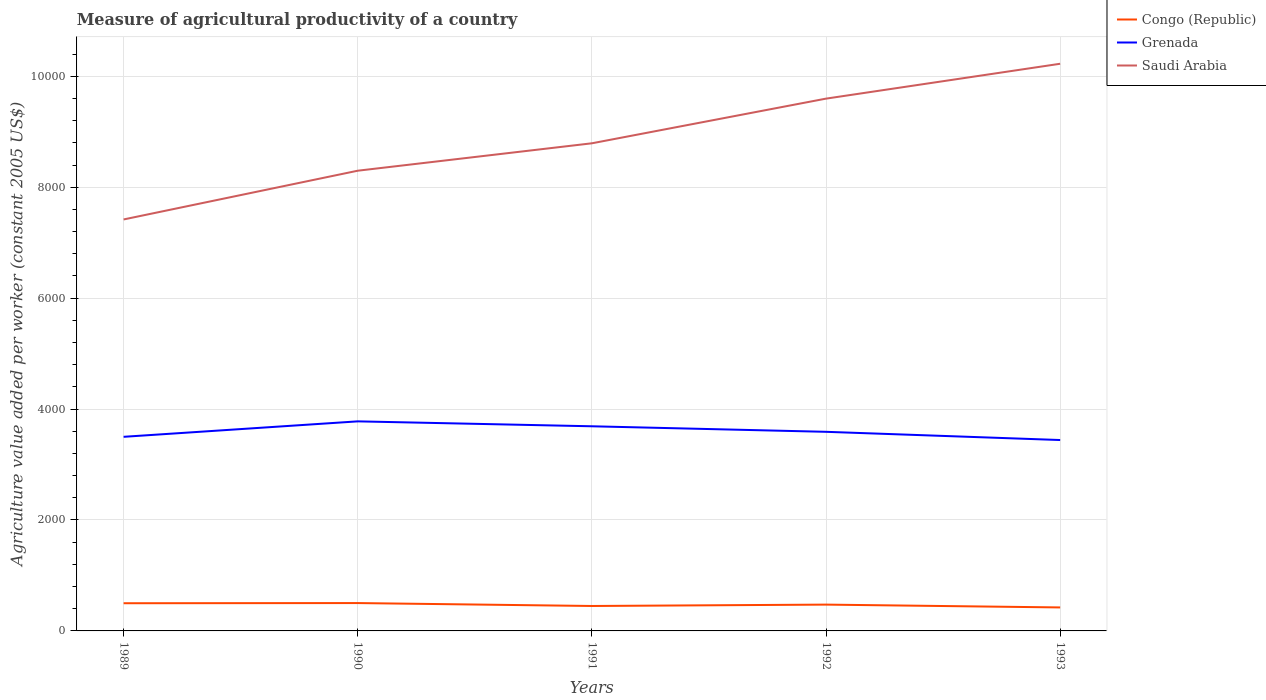How many different coloured lines are there?
Ensure brevity in your answer.  3. Does the line corresponding to Grenada intersect with the line corresponding to Saudi Arabia?
Make the answer very short. No. Across all years, what is the maximum measure of agricultural productivity in Congo (Republic)?
Your response must be concise. 423.48. What is the total measure of agricultural productivity in Grenada in the graph?
Your answer should be compact. 88.54. What is the difference between the highest and the second highest measure of agricultural productivity in Saudi Arabia?
Keep it short and to the point. 2807.13. What is the difference between the highest and the lowest measure of agricultural productivity in Saudi Arabia?
Keep it short and to the point. 2. How many lines are there?
Offer a very short reply. 3. Does the graph contain grids?
Ensure brevity in your answer.  Yes. How many legend labels are there?
Give a very brief answer. 3. What is the title of the graph?
Keep it short and to the point. Measure of agricultural productivity of a country. What is the label or title of the Y-axis?
Provide a short and direct response. Agriculture value added per worker (constant 2005 US$). What is the Agriculture value added per worker (constant 2005 US$) of Congo (Republic) in 1989?
Your answer should be very brief. 499.07. What is the Agriculture value added per worker (constant 2005 US$) of Grenada in 1989?
Ensure brevity in your answer.  3499.77. What is the Agriculture value added per worker (constant 2005 US$) of Saudi Arabia in 1989?
Your response must be concise. 7418.83. What is the Agriculture value added per worker (constant 2005 US$) in Congo (Republic) in 1990?
Provide a short and direct response. 502.42. What is the Agriculture value added per worker (constant 2005 US$) in Grenada in 1990?
Provide a short and direct response. 3778.33. What is the Agriculture value added per worker (constant 2005 US$) in Saudi Arabia in 1990?
Your answer should be compact. 8297.64. What is the Agriculture value added per worker (constant 2005 US$) of Congo (Republic) in 1991?
Offer a very short reply. 449.61. What is the Agriculture value added per worker (constant 2005 US$) of Grenada in 1991?
Offer a terse response. 3689.78. What is the Agriculture value added per worker (constant 2005 US$) in Saudi Arabia in 1991?
Keep it short and to the point. 8791.87. What is the Agriculture value added per worker (constant 2005 US$) in Congo (Republic) in 1992?
Ensure brevity in your answer.  474.3. What is the Agriculture value added per worker (constant 2005 US$) in Grenada in 1992?
Keep it short and to the point. 3590.03. What is the Agriculture value added per worker (constant 2005 US$) in Saudi Arabia in 1992?
Make the answer very short. 9597.26. What is the Agriculture value added per worker (constant 2005 US$) of Congo (Republic) in 1993?
Your answer should be compact. 423.48. What is the Agriculture value added per worker (constant 2005 US$) in Grenada in 1993?
Offer a terse response. 3441.87. What is the Agriculture value added per worker (constant 2005 US$) in Saudi Arabia in 1993?
Provide a short and direct response. 1.02e+04. Across all years, what is the maximum Agriculture value added per worker (constant 2005 US$) in Congo (Republic)?
Your answer should be very brief. 502.42. Across all years, what is the maximum Agriculture value added per worker (constant 2005 US$) of Grenada?
Ensure brevity in your answer.  3778.33. Across all years, what is the maximum Agriculture value added per worker (constant 2005 US$) in Saudi Arabia?
Offer a terse response. 1.02e+04. Across all years, what is the minimum Agriculture value added per worker (constant 2005 US$) of Congo (Republic)?
Keep it short and to the point. 423.48. Across all years, what is the minimum Agriculture value added per worker (constant 2005 US$) in Grenada?
Provide a succinct answer. 3441.87. Across all years, what is the minimum Agriculture value added per worker (constant 2005 US$) of Saudi Arabia?
Your answer should be compact. 7418.83. What is the total Agriculture value added per worker (constant 2005 US$) in Congo (Republic) in the graph?
Offer a very short reply. 2348.88. What is the total Agriculture value added per worker (constant 2005 US$) of Grenada in the graph?
Offer a terse response. 1.80e+04. What is the total Agriculture value added per worker (constant 2005 US$) in Saudi Arabia in the graph?
Offer a very short reply. 4.43e+04. What is the difference between the Agriculture value added per worker (constant 2005 US$) of Congo (Republic) in 1989 and that in 1990?
Your answer should be very brief. -3.35. What is the difference between the Agriculture value added per worker (constant 2005 US$) of Grenada in 1989 and that in 1990?
Offer a terse response. -278.56. What is the difference between the Agriculture value added per worker (constant 2005 US$) of Saudi Arabia in 1989 and that in 1990?
Your answer should be very brief. -878.81. What is the difference between the Agriculture value added per worker (constant 2005 US$) of Congo (Republic) in 1989 and that in 1991?
Offer a very short reply. 49.46. What is the difference between the Agriculture value added per worker (constant 2005 US$) of Grenada in 1989 and that in 1991?
Your answer should be compact. -190.01. What is the difference between the Agriculture value added per worker (constant 2005 US$) in Saudi Arabia in 1989 and that in 1991?
Keep it short and to the point. -1373.04. What is the difference between the Agriculture value added per worker (constant 2005 US$) of Congo (Republic) in 1989 and that in 1992?
Provide a short and direct response. 24.77. What is the difference between the Agriculture value added per worker (constant 2005 US$) in Grenada in 1989 and that in 1992?
Your answer should be compact. -90.26. What is the difference between the Agriculture value added per worker (constant 2005 US$) of Saudi Arabia in 1989 and that in 1992?
Keep it short and to the point. -2178.43. What is the difference between the Agriculture value added per worker (constant 2005 US$) of Congo (Republic) in 1989 and that in 1993?
Make the answer very short. 75.59. What is the difference between the Agriculture value added per worker (constant 2005 US$) of Grenada in 1989 and that in 1993?
Give a very brief answer. 57.9. What is the difference between the Agriculture value added per worker (constant 2005 US$) in Saudi Arabia in 1989 and that in 1993?
Provide a succinct answer. -2807.13. What is the difference between the Agriculture value added per worker (constant 2005 US$) in Congo (Republic) in 1990 and that in 1991?
Your answer should be very brief. 52.81. What is the difference between the Agriculture value added per worker (constant 2005 US$) in Grenada in 1990 and that in 1991?
Ensure brevity in your answer.  88.54. What is the difference between the Agriculture value added per worker (constant 2005 US$) in Saudi Arabia in 1990 and that in 1991?
Give a very brief answer. -494.23. What is the difference between the Agriculture value added per worker (constant 2005 US$) of Congo (Republic) in 1990 and that in 1992?
Ensure brevity in your answer.  28.12. What is the difference between the Agriculture value added per worker (constant 2005 US$) in Grenada in 1990 and that in 1992?
Give a very brief answer. 188.3. What is the difference between the Agriculture value added per worker (constant 2005 US$) of Saudi Arabia in 1990 and that in 1992?
Ensure brevity in your answer.  -1299.62. What is the difference between the Agriculture value added per worker (constant 2005 US$) of Congo (Republic) in 1990 and that in 1993?
Offer a terse response. 78.95. What is the difference between the Agriculture value added per worker (constant 2005 US$) of Grenada in 1990 and that in 1993?
Make the answer very short. 336.46. What is the difference between the Agriculture value added per worker (constant 2005 US$) in Saudi Arabia in 1990 and that in 1993?
Provide a short and direct response. -1928.32. What is the difference between the Agriculture value added per worker (constant 2005 US$) in Congo (Republic) in 1991 and that in 1992?
Keep it short and to the point. -24.69. What is the difference between the Agriculture value added per worker (constant 2005 US$) in Grenada in 1991 and that in 1992?
Your answer should be very brief. 99.75. What is the difference between the Agriculture value added per worker (constant 2005 US$) in Saudi Arabia in 1991 and that in 1992?
Your answer should be very brief. -805.39. What is the difference between the Agriculture value added per worker (constant 2005 US$) of Congo (Republic) in 1991 and that in 1993?
Offer a very short reply. 26.13. What is the difference between the Agriculture value added per worker (constant 2005 US$) of Grenada in 1991 and that in 1993?
Give a very brief answer. 247.91. What is the difference between the Agriculture value added per worker (constant 2005 US$) in Saudi Arabia in 1991 and that in 1993?
Provide a short and direct response. -1434.09. What is the difference between the Agriculture value added per worker (constant 2005 US$) in Congo (Republic) in 1992 and that in 1993?
Make the answer very short. 50.83. What is the difference between the Agriculture value added per worker (constant 2005 US$) of Grenada in 1992 and that in 1993?
Provide a succinct answer. 148.16. What is the difference between the Agriculture value added per worker (constant 2005 US$) of Saudi Arabia in 1992 and that in 1993?
Ensure brevity in your answer.  -628.7. What is the difference between the Agriculture value added per worker (constant 2005 US$) in Congo (Republic) in 1989 and the Agriculture value added per worker (constant 2005 US$) in Grenada in 1990?
Provide a succinct answer. -3279.26. What is the difference between the Agriculture value added per worker (constant 2005 US$) of Congo (Republic) in 1989 and the Agriculture value added per worker (constant 2005 US$) of Saudi Arabia in 1990?
Make the answer very short. -7798.57. What is the difference between the Agriculture value added per worker (constant 2005 US$) of Grenada in 1989 and the Agriculture value added per worker (constant 2005 US$) of Saudi Arabia in 1990?
Ensure brevity in your answer.  -4797.87. What is the difference between the Agriculture value added per worker (constant 2005 US$) of Congo (Republic) in 1989 and the Agriculture value added per worker (constant 2005 US$) of Grenada in 1991?
Provide a short and direct response. -3190.71. What is the difference between the Agriculture value added per worker (constant 2005 US$) in Congo (Republic) in 1989 and the Agriculture value added per worker (constant 2005 US$) in Saudi Arabia in 1991?
Your answer should be very brief. -8292.8. What is the difference between the Agriculture value added per worker (constant 2005 US$) of Grenada in 1989 and the Agriculture value added per worker (constant 2005 US$) of Saudi Arabia in 1991?
Keep it short and to the point. -5292.1. What is the difference between the Agriculture value added per worker (constant 2005 US$) of Congo (Republic) in 1989 and the Agriculture value added per worker (constant 2005 US$) of Grenada in 1992?
Your answer should be very brief. -3090.96. What is the difference between the Agriculture value added per worker (constant 2005 US$) of Congo (Republic) in 1989 and the Agriculture value added per worker (constant 2005 US$) of Saudi Arabia in 1992?
Your response must be concise. -9098.19. What is the difference between the Agriculture value added per worker (constant 2005 US$) in Grenada in 1989 and the Agriculture value added per worker (constant 2005 US$) in Saudi Arabia in 1992?
Your response must be concise. -6097.49. What is the difference between the Agriculture value added per worker (constant 2005 US$) in Congo (Republic) in 1989 and the Agriculture value added per worker (constant 2005 US$) in Grenada in 1993?
Provide a succinct answer. -2942.8. What is the difference between the Agriculture value added per worker (constant 2005 US$) of Congo (Republic) in 1989 and the Agriculture value added per worker (constant 2005 US$) of Saudi Arabia in 1993?
Give a very brief answer. -9726.89. What is the difference between the Agriculture value added per worker (constant 2005 US$) in Grenada in 1989 and the Agriculture value added per worker (constant 2005 US$) in Saudi Arabia in 1993?
Your answer should be compact. -6726.19. What is the difference between the Agriculture value added per worker (constant 2005 US$) in Congo (Republic) in 1990 and the Agriculture value added per worker (constant 2005 US$) in Grenada in 1991?
Your response must be concise. -3187.36. What is the difference between the Agriculture value added per worker (constant 2005 US$) in Congo (Republic) in 1990 and the Agriculture value added per worker (constant 2005 US$) in Saudi Arabia in 1991?
Keep it short and to the point. -8289.45. What is the difference between the Agriculture value added per worker (constant 2005 US$) in Grenada in 1990 and the Agriculture value added per worker (constant 2005 US$) in Saudi Arabia in 1991?
Your answer should be compact. -5013.55. What is the difference between the Agriculture value added per worker (constant 2005 US$) in Congo (Republic) in 1990 and the Agriculture value added per worker (constant 2005 US$) in Grenada in 1992?
Keep it short and to the point. -3087.6. What is the difference between the Agriculture value added per worker (constant 2005 US$) of Congo (Republic) in 1990 and the Agriculture value added per worker (constant 2005 US$) of Saudi Arabia in 1992?
Your answer should be very brief. -9094.84. What is the difference between the Agriculture value added per worker (constant 2005 US$) in Grenada in 1990 and the Agriculture value added per worker (constant 2005 US$) in Saudi Arabia in 1992?
Provide a short and direct response. -5818.94. What is the difference between the Agriculture value added per worker (constant 2005 US$) of Congo (Republic) in 1990 and the Agriculture value added per worker (constant 2005 US$) of Grenada in 1993?
Provide a succinct answer. -2939.45. What is the difference between the Agriculture value added per worker (constant 2005 US$) in Congo (Republic) in 1990 and the Agriculture value added per worker (constant 2005 US$) in Saudi Arabia in 1993?
Keep it short and to the point. -9723.54. What is the difference between the Agriculture value added per worker (constant 2005 US$) in Grenada in 1990 and the Agriculture value added per worker (constant 2005 US$) in Saudi Arabia in 1993?
Keep it short and to the point. -6447.64. What is the difference between the Agriculture value added per worker (constant 2005 US$) in Congo (Republic) in 1991 and the Agriculture value added per worker (constant 2005 US$) in Grenada in 1992?
Offer a terse response. -3140.42. What is the difference between the Agriculture value added per worker (constant 2005 US$) in Congo (Republic) in 1991 and the Agriculture value added per worker (constant 2005 US$) in Saudi Arabia in 1992?
Provide a short and direct response. -9147.65. What is the difference between the Agriculture value added per worker (constant 2005 US$) of Grenada in 1991 and the Agriculture value added per worker (constant 2005 US$) of Saudi Arabia in 1992?
Keep it short and to the point. -5907.48. What is the difference between the Agriculture value added per worker (constant 2005 US$) of Congo (Republic) in 1991 and the Agriculture value added per worker (constant 2005 US$) of Grenada in 1993?
Provide a short and direct response. -2992.26. What is the difference between the Agriculture value added per worker (constant 2005 US$) of Congo (Republic) in 1991 and the Agriculture value added per worker (constant 2005 US$) of Saudi Arabia in 1993?
Offer a terse response. -9776.35. What is the difference between the Agriculture value added per worker (constant 2005 US$) of Grenada in 1991 and the Agriculture value added per worker (constant 2005 US$) of Saudi Arabia in 1993?
Provide a short and direct response. -6536.18. What is the difference between the Agriculture value added per worker (constant 2005 US$) of Congo (Republic) in 1992 and the Agriculture value added per worker (constant 2005 US$) of Grenada in 1993?
Offer a terse response. -2967.57. What is the difference between the Agriculture value added per worker (constant 2005 US$) of Congo (Republic) in 1992 and the Agriculture value added per worker (constant 2005 US$) of Saudi Arabia in 1993?
Make the answer very short. -9751.66. What is the difference between the Agriculture value added per worker (constant 2005 US$) of Grenada in 1992 and the Agriculture value added per worker (constant 2005 US$) of Saudi Arabia in 1993?
Your answer should be very brief. -6635.94. What is the average Agriculture value added per worker (constant 2005 US$) in Congo (Republic) per year?
Keep it short and to the point. 469.78. What is the average Agriculture value added per worker (constant 2005 US$) in Grenada per year?
Offer a very short reply. 3599.96. What is the average Agriculture value added per worker (constant 2005 US$) of Saudi Arabia per year?
Provide a short and direct response. 8866.31. In the year 1989, what is the difference between the Agriculture value added per worker (constant 2005 US$) in Congo (Republic) and Agriculture value added per worker (constant 2005 US$) in Grenada?
Your answer should be very brief. -3000.7. In the year 1989, what is the difference between the Agriculture value added per worker (constant 2005 US$) in Congo (Republic) and Agriculture value added per worker (constant 2005 US$) in Saudi Arabia?
Give a very brief answer. -6919.76. In the year 1989, what is the difference between the Agriculture value added per worker (constant 2005 US$) of Grenada and Agriculture value added per worker (constant 2005 US$) of Saudi Arabia?
Make the answer very short. -3919.06. In the year 1990, what is the difference between the Agriculture value added per worker (constant 2005 US$) in Congo (Republic) and Agriculture value added per worker (constant 2005 US$) in Grenada?
Give a very brief answer. -3275.9. In the year 1990, what is the difference between the Agriculture value added per worker (constant 2005 US$) of Congo (Republic) and Agriculture value added per worker (constant 2005 US$) of Saudi Arabia?
Provide a short and direct response. -7795.22. In the year 1990, what is the difference between the Agriculture value added per worker (constant 2005 US$) of Grenada and Agriculture value added per worker (constant 2005 US$) of Saudi Arabia?
Your answer should be compact. -4519.32. In the year 1991, what is the difference between the Agriculture value added per worker (constant 2005 US$) of Congo (Republic) and Agriculture value added per worker (constant 2005 US$) of Grenada?
Offer a very short reply. -3240.17. In the year 1991, what is the difference between the Agriculture value added per worker (constant 2005 US$) of Congo (Republic) and Agriculture value added per worker (constant 2005 US$) of Saudi Arabia?
Provide a short and direct response. -8342.26. In the year 1991, what is the difference between the Agriculture value added per worker (constant 2005 US$) in Grenada and Agriculture value added per worker (constant 2005 US$) in Saudi Arabia?
Your response must be concise. -5102.09. In the year 1992, what is the difference between the Agriculture value added per worker (constant 2005 US$) in Congo (Republic) and Agriculture value added per worker (constant 2005 US$) in Grenada?
Give a very brief answer. -3115.73. In the year 1992, what is the difference between the Agriculture value added per worker (constant 2005 US$) of Congo (Republic) and Agriculture value added per worker (constant 2005 US$) of Saudi Arabia?
Offer a very short reply. -9122.96. In the year 1992, what is the difference between the Agriculture value added per worker (constant 2005 US$) in Grenada and Agriculture value added per worker (constant 2005 US$) in Saudi Arabia?
Your answer should be very brief. -6007.23. In the year 1993, what is the difference between the Agriculture value added per worker (constant 2005 US$) in Congo (Republic) and Agriculture value added per worker (constant 2005 US$) in Grenada?
Give a very brief answer. -3018.39. In the year 1993, what is the difference between the Agriculture value added per worker (constant 2005 US$) of Congo (Republic) and Agriculture value added per worker (constant 2005 US$) of Saudi Arabia?
Provide a short and direct response. -9802.49. In the year 1993, what is the difference between the Agriculture value added per worker (constant 2005 US$) of Grenada and Agriculture value added per worker (constant 2005 US$) of Saudi Arabia?
Offer a terse response. -6784.09. What is the ratio of the Agriculture value added per worker (constant 2005 US$) of Congo (Republic) in 1989 to that in 1990?
Offer a very short reply. 0.99. What is the ratio of the Agriculture value added per worker (constant 2005 US$) in Grenada in 1989 to that in 1990?
Keep it short and to the point. 0.93. What is the ratio of the Agriculture value added per worker (constant 2005 US$) of Saudi Arabia in 1989 to that in 1990?
Offer a very short reply. 0.89. What is the ratio of the Agriculture value added per worker (constant 2005 US$) in Congo (Republic) in 1989 to that in 1991?
Make the answer very short. 1.11. What is the ratio of the Agriculture value added per worker (constant 2005 US$) of Grenada in 1989 to that in 1991?
Provide a succinct answer. 0.95. What is the ratio of the Agriculture value added per worker (constant 2005 US$) of Saudi Arabia in 1989 to that in 1991?
Provide a short and direct response. 0.84. What is the ratio of the Agriculture value added per worker (constant 2005 US$) in Congo (Republic) in 1989 to that in 1992?
Make the answer very short. 1.05. What is the ratio of the Agriculture value added per worker (constant 2005 US$) in Grenada in 1989 to that in 1992?
Give a very brief answer. 0.97. What is the ratio of the Agriculture value added per worker (constant 2005 US$) of Saudi Arabia in 1989 to that in 1992?
Keep it short and to the point. 0.77. What is the ratio of the Agriculture value added per worker (constant 2005 US$) of Congo (Republic) in 1989 to that in 1993?
Provide a short and direct response. 1.18. What is the ratio of the Agriculture value added per worker (constant 2005 US$) of Grenada in 1989 to that in 1993?
Give a very brief answer. 1.02. What is the ratio of the Agriculture value added per worker (constant 2005 US$) in Saudi Arabia in 1989 to that in 1993?
Offer a terse response. 0.73. What is the ratio of the Agriculture value added per worker (constant 2005 US$) in Congo (Republic) in 1990 to that in 1991?
Your answer should be very brief. 1.12. What is the ratio of the Agriculture value added per worker (constant 2005 US$) in Grenada in 1990 to that in 1991?
Your answer should be very brief. 1.02. What is the ratio of the Agriculture value added per worker (constant 2005 US$) of Saudi Arabia in 1990 to that in 1991?
Keep it short and to the point. 0.94. What is the ratio of the Agriculture value added per worker (constant 2005 US$) of Congo (Republic) in 1990 to that in 1992?
Your response must be concise. 1.06. What is the ratio of the Agriculture value added per worker (constant 2005 US$) in Grenada in 1990 to that in 1992?
Your answer should be compact. 1.05. What is the ratio of the Agriculture value added per worker (constant 2005 US$) in Saudi Arabia in 1990 to that in 1992?
Offer a very short reply. 0.86. What is the ratio of the Agriculture value added per worker (constant 2005 US$) in Congo (Republic) in 1990 to that in 1993?
Offer a very short reply. 1.19. What is the ratio of the Agriculture value added per worker (constant 2005 US$) in Grenada in 1990 to that in 1993?
Provide a succinct answer. 1.1. What is the ratio of the Agriculture value added per worker (constant 2005 US$) in Saudi Arabia in 1990 to that in 1993?
Provide a short and direct response. 0.81. What is the ratio of the Agriculture value added per worker (constant 2005 US$) in Congo (Republic) in 1991 to that in 1992?
Keep it short and to the point. 0.95. What is the ratio of the Agriculture value added per worker (constant 2005 US$) in Grenada in 1991 to that in 1992?
Your answer should be compact. 1.03. What is the ratio of the Agriculture value added per worker (constant 2005 US$) in Saudi Arabia in 1991 to that in 1992?
Offer a very short reply. 0.92. What is the ratio of the Agriculture value added per worker (constant 2005 US$) of Congo (Republic) in 1991 to that in 1993?
Your answer should be very brief. 1.06. What is the ratio of the Agriculture value added per worker (constant 2005 US$) in Grenada in 1991 to that in 1993?
Your response must be concise. 1.07. What is the ratio of the Agriculture value added per worker (constant 2005 US$) in Saudi Arabia in 1991 to that in 1993?
Give a very brief answer. 0.86. What is the ratio of the Agriculture value added per worker (constant 2005 US$) in Congo (Republic) in 1992 to that in 1993?
Make the answer very short. 1.12. What is the ratio of the Agriculture value added per worker (constant 2005 US$) in Grenada in 1992 to that in 1993?
Keep it short and to the point. 1.04. What is the ratio of the Agriculture value added per worker (constant 2005 US$) of Saudi Arabia in 1992 to that in 1993?
Provide a short and direct response. 0.94. What is the difference between the highest and the second highest Agriculture value added per worker (constant 2005 US$) of Congo (Republic)?
Give a very brief answer. 3.35. What is the difference between the highest and the second highest Agriculture value added per worker (constant 2005 US$) of Grenada?
Provide a succinct answer. 88.54. What is the difference between the highest and the second highest Agriculture value added per worker (constant 2005 US$) in Saudi Arabia?
Your answer should be compact. 628.7. What is the difference between the highest and the lowest Agriculture value added per worker (constant 2005 US$) of Congo (Republic)?
Provide a succinct answer. 78.95. What is the difference between the highest and the lowest Agriculture value added per worker (constant 2005 US$) in Grenada?
Your answer should be compact. 336.46. What is the difference between the highest and the lowest Agriculture value added per worker (constant 2005 US$) of Saudi Arabia?
Provide a short and direct response. 2807.13. 